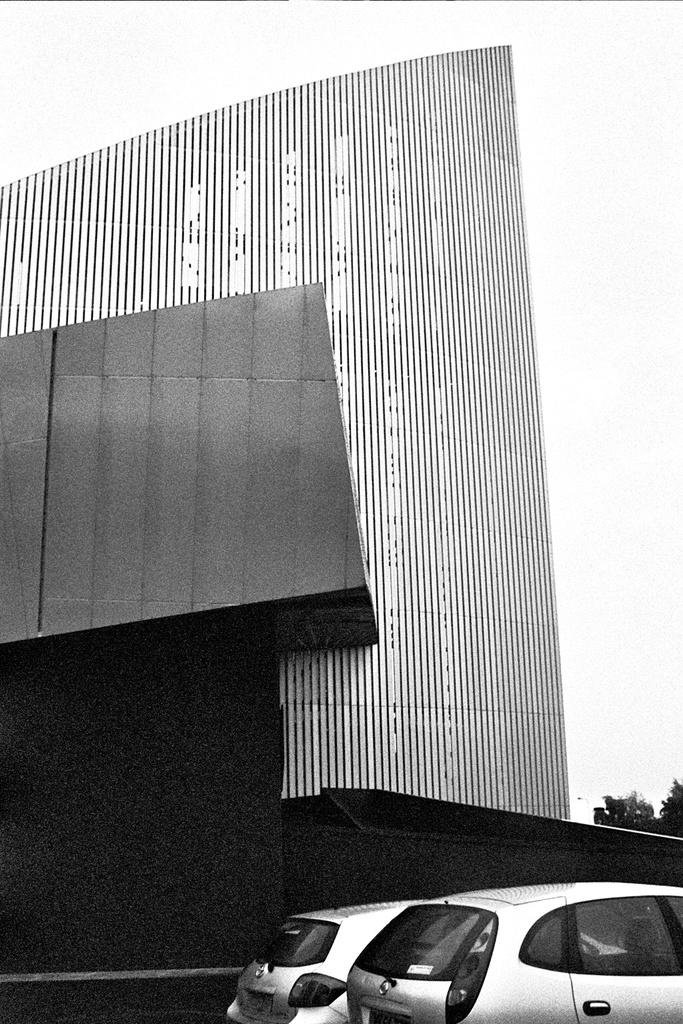What type of vehicles can be seen in the image? There are cars in the image. What is located behind the cars? There is a building behind the cars. What type of vegetation is present in the image? There are trees in the image. Where is the lunchroom located in the image? There is no mention of a lunchroom in the image; it only features cars, a building, and trees. 